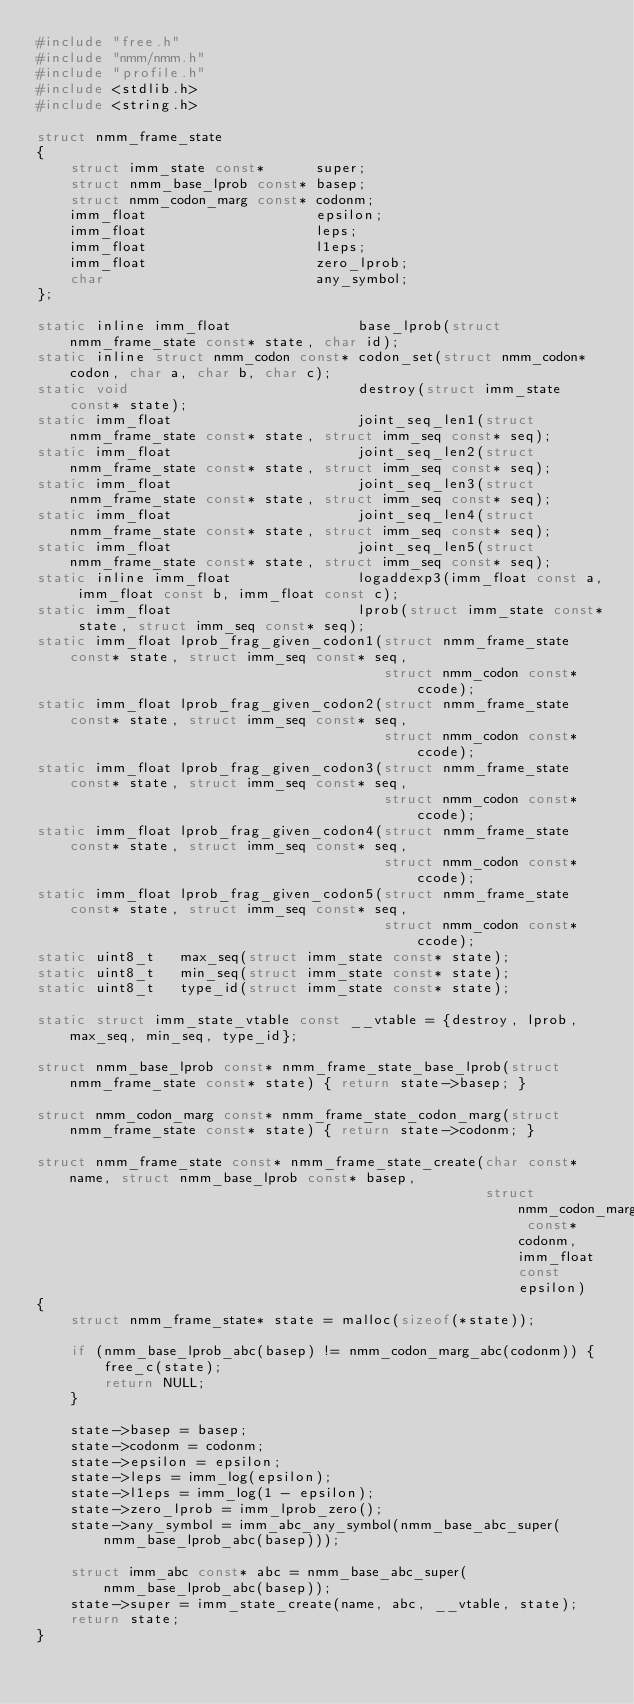<code> <loc_0><loc_0><loc_500><loc_500><_C_>#include "free.h"
#include "nmm/nmm.h"
#include "profile.h"
#include <stdlib.h>
#include <string.h>

struct nmm_frame_state
{
    struct imm_state const*      super;
    struct nmm_base_lprob const* basep;
    struct nmm_codon_marg const* codonm;
    imm_float                    epsilon;
    imm_float                    leps;
    imm_float                    l1eps;
    imm_float                    zero_lprob;
    char                         any_symbol;
};

static inline imm_float               base_lprob(struct nmm_frame_state const* state, char id);
static inline struct nmm_codon const* codon_set(struct nmm_codon* codon, char a, char b, char c);
static void                           destroy(struct imm_state const* state);
static imm_float                      joint_seq_len1(struct nmm_frame_state const* state, struct imm_seq const* seq);
static imm_float                      joint_seq_len2(struct nmm_frame_state const* state, struct imm_seq const* seq);
static imm_float                      joint_seq_len3(struct nmm_frame_state const* state, struct imm_seq const* seq);
static imm_float                      joint_seq_len4(struct nmm_frame_state const* state, struct imm_seq const* seq);
static imm_float                      joint_seq_len5(struct nmm_frame_state const* state, struct imm_seq const* seq);
static inline imm_float               logaddexp3(imm_float const a, imm_float const b, imm_float const c);
static imm_float                      lprob(struct imm_state const* state, struct imm_seq const* seq);
static imm_float lprob_frag_given_codon1(struct nmm_frame_state const* state, struct imm_seq const* seq,
                                         struct nmm_codon const* ccode);
static imm_float lprob_frag_given_codon2(struct nmm_frame_state const* state, struct imm_seq const* seq,
                                         struct nmm_codon const* ccode);
static imm_float lprob_frag_given_codon3(struct nmm_frame_state const* state, struct imm_seq const* seq,
                                         struct nmm_codon const* ccode);
static imm_float lprob_frag_given_codon4(struct nmm_frame_state const* state, struct imm_seq const* seq,
                                         struct nmm_codon const* ccode);
static imm_float lprob_frag_given_codon5(struct nmm_frame_state const* state, struct imm_seq const* seq,
                                         struct nmm_codon const* ccode);
static uint8_t   max_seq(struct imm_state const* state);
static uint8_t   min_seq(struct imm_state const* state);
static uint8_t   type_id(struct imm_state const* state);

static struct imm_state_vtable const __vtable = {destroy, lprob, max_seq, min_seq, type_id};

struct nmm_base_lprob const* nmm_frame_state_base_lprob(struct nmm_frame_state const* state) { return state->basep; }

struct nmm_codon_marg const* nmm_frame_state_codon_marg(struct nmm_frame_state const* state) { return state->codonm; }

struct nmm_frame_state const* nmm_frame_state_create(char const* name, struct nmm_base_lprob const* basep,
                                                     struct nmm_codon_marg const* codonm, imm_float const epsilon)
{
    struct nmm_frame_state* state = malloc(sizeof(*state));

    if (nmm_base_lprob_abc(basep) != nmm_codon_marg_abc(codonm)) {
        free_c(state);
        return NULL;
    }

    state->basep = basep;
    state->codonm = codonm;
    state->epsilon = epsilon;
    state->leps = imm_log(epsilon);
    state->l1eps = imm_log(1 - epsilon);
    state->zero_lprob = imm_lprob_zero();
    state->any_symbol = imm_abc_any_symbol(nmm_base_abc_super(nmm_base_lprob_abc(basep)));

    struct imm_abc const* abc = nmm_base_abc_super(nmm_base_lprob_abc(basep));
    state->super = imm_state_create(name, abc, __vtable, state);
    return state;
}
</code> 